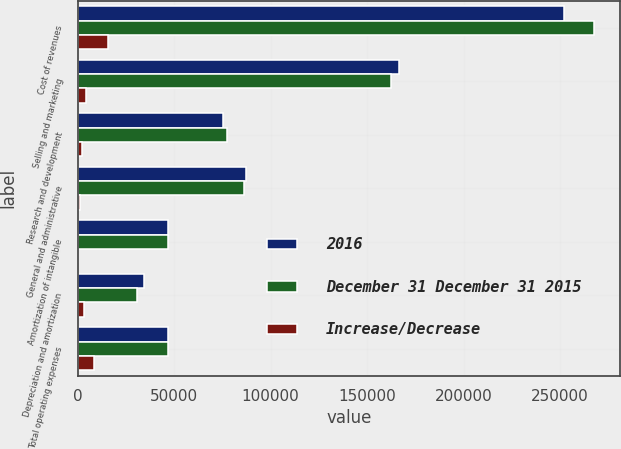Convert chart. <chart><loc_0><loc_0><loc_500><loc_500><stacked_bar_chart><ecel><fcel>Cost of revenues<fcel>Selling and marketing<fcel>Research and development<fcel>General and administrative<fcel>Amortization of intangible<fcel>Depreciation and amortization<fcel>Total operating expenses<nl><fcel>2016<fcel>252107<fcel>166666<fcel>75204<fcel>87235<fcel>47033<fcel>34320<fcel>46910<nl><fcel>December 31 December 31 2015<fcel>267695<fcel>162294<fcel>77320<fcel>86007<fcel>46910<fcel>30889<fcel>46910<nl><fcel>Increase/Decrease<fcel>15588<fcel>4372<fcel>2116<fcel>1228<fcel>123<fcel>3431<fcel>8550<nl></chart> 